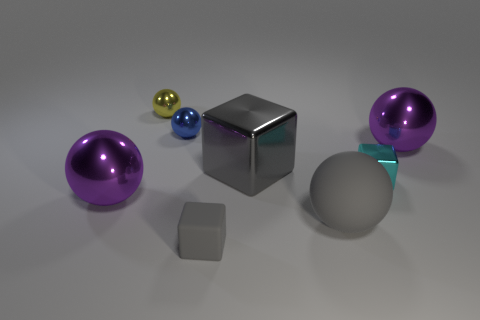Subtract all big gray blocks. How many blocks are left? 2 Subtract all cyan blocks. How many blocks are left? 2 Subtract all blocks. How many objects are left? 5 Add 2 big shiny objects. How many objects exist? 10 Subtract all blue balls. How many gray blocks are left? 2 Add 5 gray spheres. How many gray spheres are left? 6 Add 1 tiny blue matte cylinders. How many tiny blue matte cylinders exist? 1 Subtract 0 yellow blocks. How many objects are left? 8 Subtract 1 cubes. How many cubes are left? 2 Subtract all green spheres. Subtract all cyan blocks. How many spheres are left? 5 